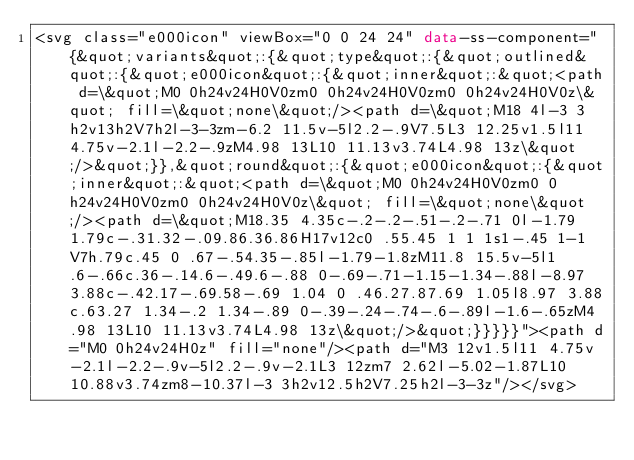Convert code to text. <code><loc_0><loc_0><loc_500><loc_500><_HTML_><svg class="e000icon" viewBox="0 0 24 24" data-ss-component="{&quot;variants&quot;:{&quot;type&quot;:{&quot;outlined&quot;:{&quot;e000icon&quot;:{&quot;inner&quot;:&quot;<path d=\&quot;M0 0h24v24H0V0zm0 0h24v24H0V0zm0 0h24v24H0V0z\&quot; fill=\&quot;none\&quot;/><path d=\&quot;M18 4l-3 3h2v13h2V7h2l-3-3zm-6.2 11.5v-5l2.2-.9V7.5L3 12.25v1.5l11 4.75v-2.1l-2.2-.9zM4.98 13L10 11.13v3.74L4.98 13z\&quot;/>&quot;}},&quot;round&quot;:{&quot;e000icon&quot;:{&quot;inner&quot;:&quot;<path d=\&quot;M0 0h24v24H0V0zm0 0h24v24H0V0zm0 0h24v24H0V0z\&quot; fill=\&quot;none\&quot;/><path d=\&quot;M18.35 4.35c-.2-.2-.51-.2-.71 0l-1.79 1.79c-.31.32-.09.86.36.86H17v12c0 .55.45 1 1 1s1-.45 1-1V7h.79c.45 0 .67-.54.35-.85l-1.79-1.8zM11.8 15.5v-5l1.6-.66c.36-.14.6-.49.6-.88 0-.69-.71-1.15-1.34-.88l-8.97 3.88c-.42.17-.69.58-.69 1.04 0 .46.27.87.69 1.05l8.97 3.88c.63.27 1.34-.2 1.34-.89 0-.39-.24-.74-.6-.89l-1.6-.65zM4.98 13L10 11.13v3.74L4.98 13z\&quot;/>&quot;}}}}}"><path d="M0 0h24v24H0z" fill="none"/><path d="M3 12v1.5l11 4.75v-2.1l-2.2-.9v-5l2.2-.9v-2.1L3 12zm7 2.62l-5.02-1.87L10 10.88v3.74zm8-10.37l-3 3h2v12.5h2V7.25h2l-3-3z"/></svg></code> 